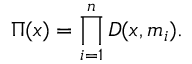<formula> <loc_0><loc_0><loc_500><loc_500>\Pi ( x ) = \prod _ { i = 1 } ^ { n } D ( x , m _ { i } ) .</formula> 